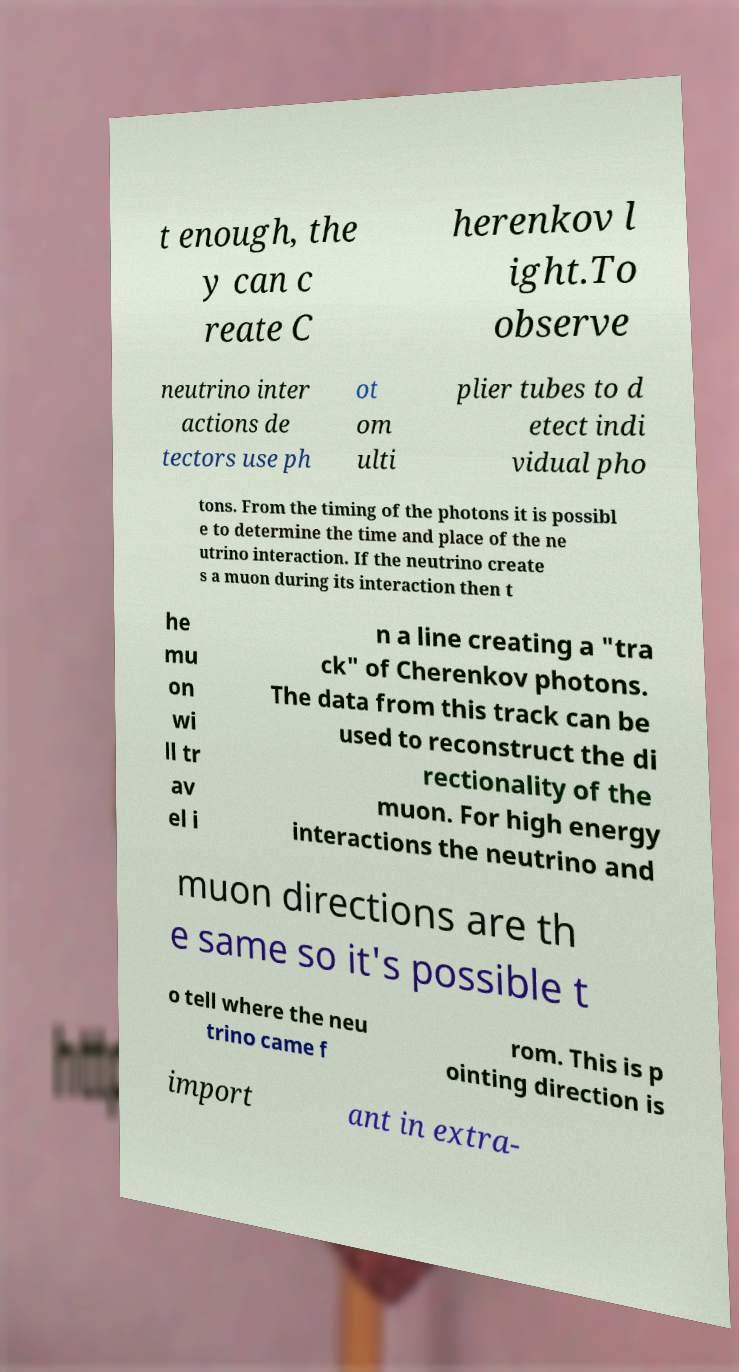There's text embedded in this image that I need extracted. Can you transcribe it verbatim? t enough, the y can c reate C herenkov l ight.To observe neutrino inter actions de tectors use ph ot om ulti plier tubes to d etect indi vidual pho tons. From the timing of the photons it is possibl e to determine the time and place of the ne utrino interaction. If the neutrino create s a muon during its interaction then t he mu on wi ll tr av el i n a line creating a "tra ck" of Cherenkov photons. The data from this track can be used to reconstruct the di rectionality of the muon. For high energy interactions the neutrino and muon directions are th e same so it's possible t o tell where the neu trino came f rom. This is p ointing direction is import ant in extra- 